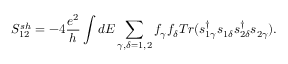<formula> <loc_0><loc_0><loc_500><loc_500>{ S _ { 1 2 } ^ { s h } } = - 4 \frac { e ^ { 2 } } { h } \int d E \sum _ { \gamma , \delta = 1 , 2 } f _ { \gamma } f _ { \delta } T r ( s _ { 1 \gamma } ^ { \dagger } s _ { 1 \delta } s _ { 2 \delta } ^ { \dagger } s _ { 2 \gamma } ) .</formula> 